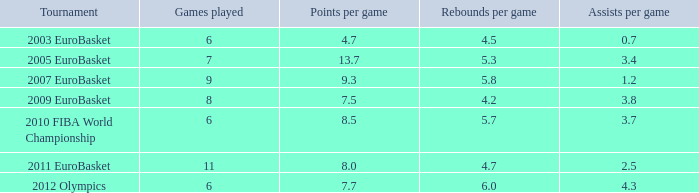How many games played feature 6.0. 